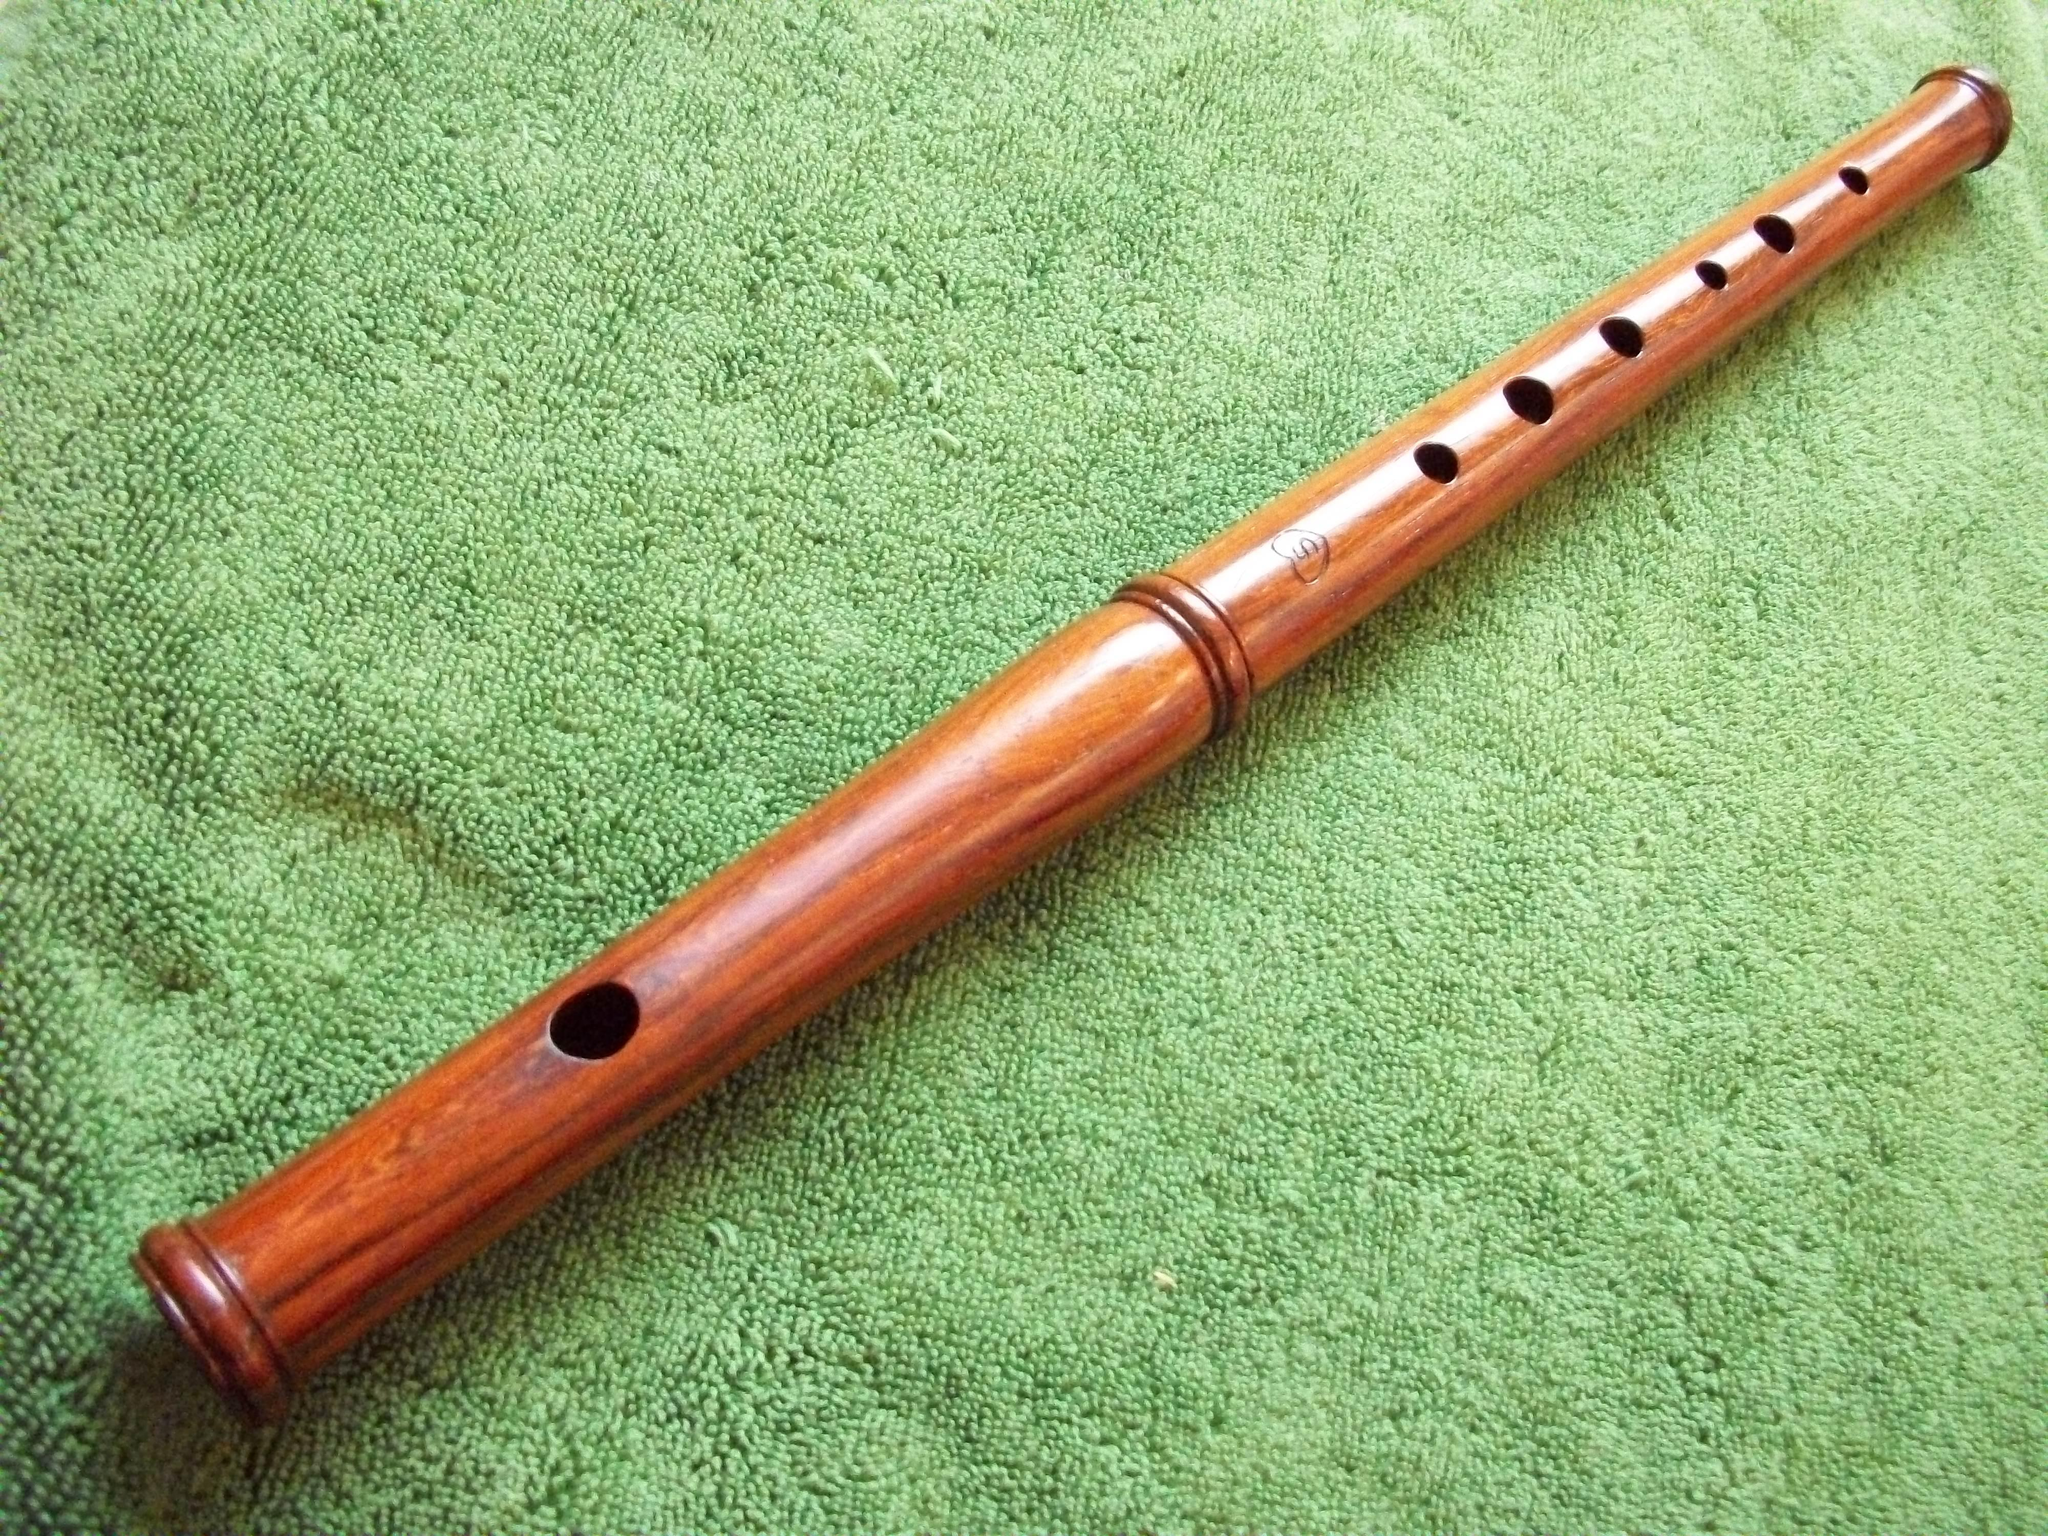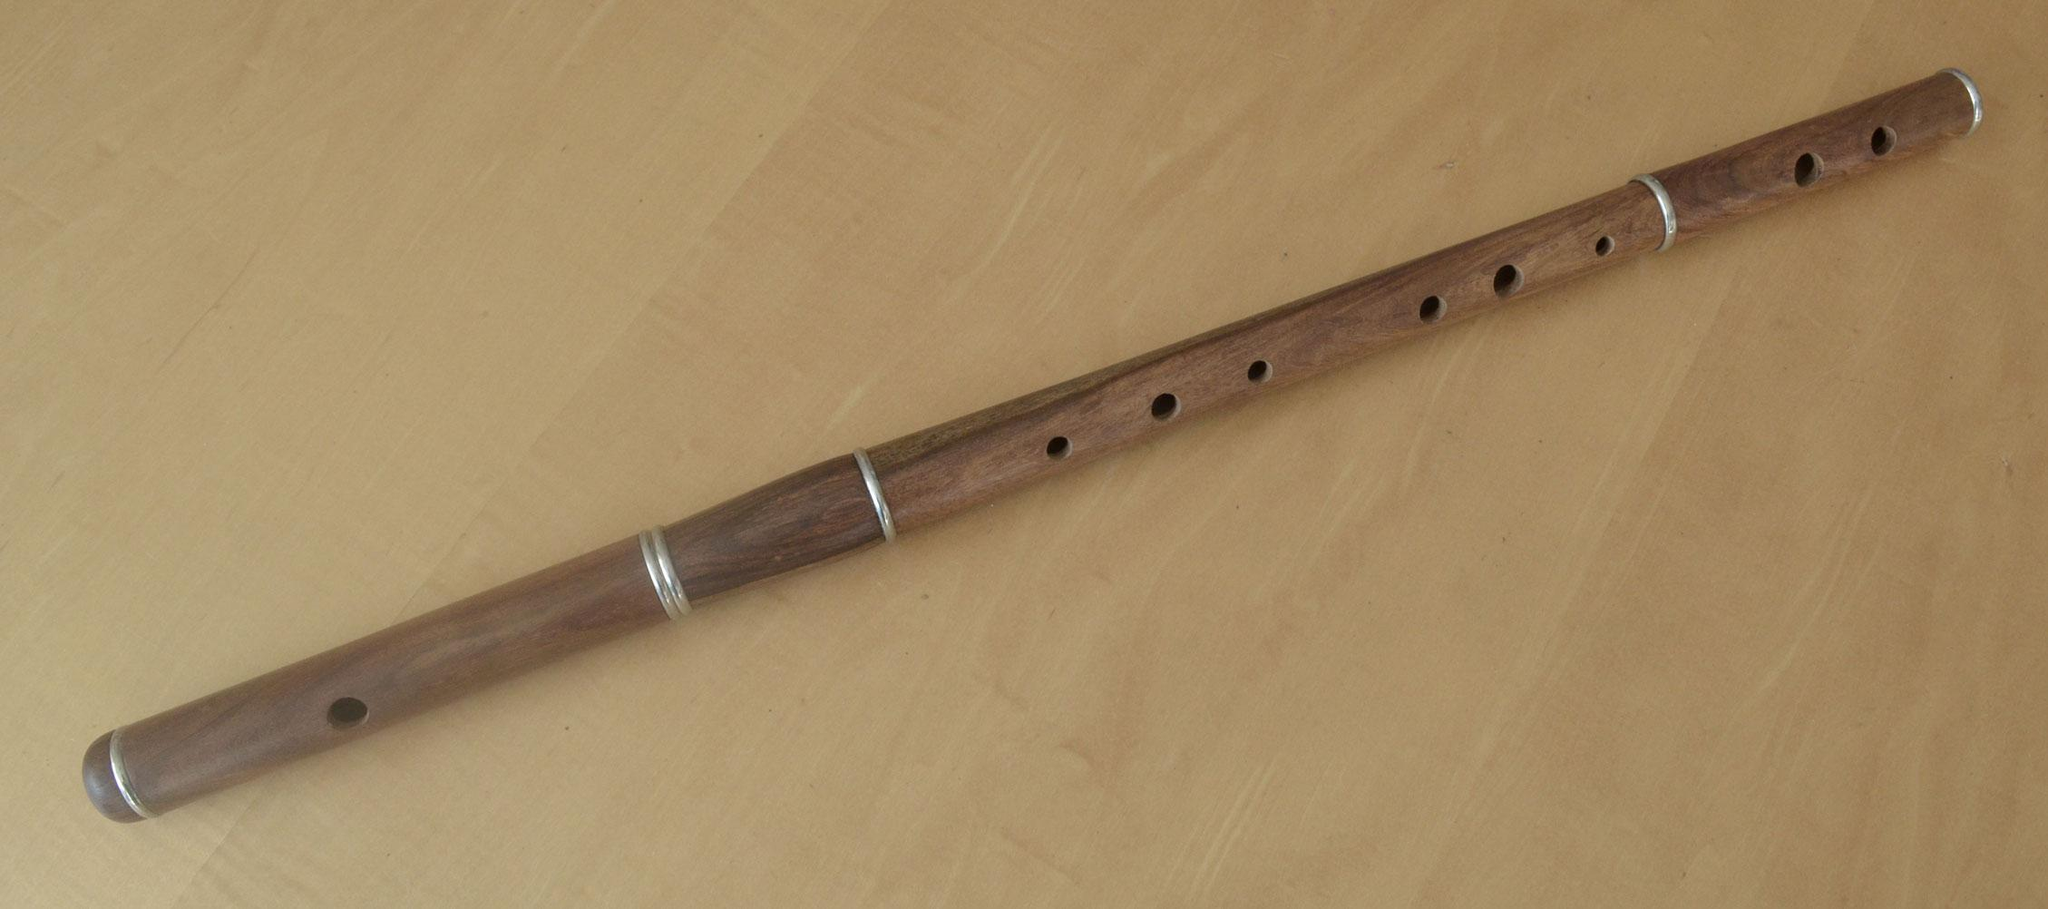The first image is the image on the left, the second image is the image on the right. Evaluate the accuracy of this statement regarding the images: "One image contains at least two flute sticks positioned with one end together and the other end fanning out.". Is it true? Answer yes or no. No. The first image is the image on the left, the second image is the image on the right. Considering the images on both sides, is "There are exactly two flutes." valid? Answer yes or no. Yes. 